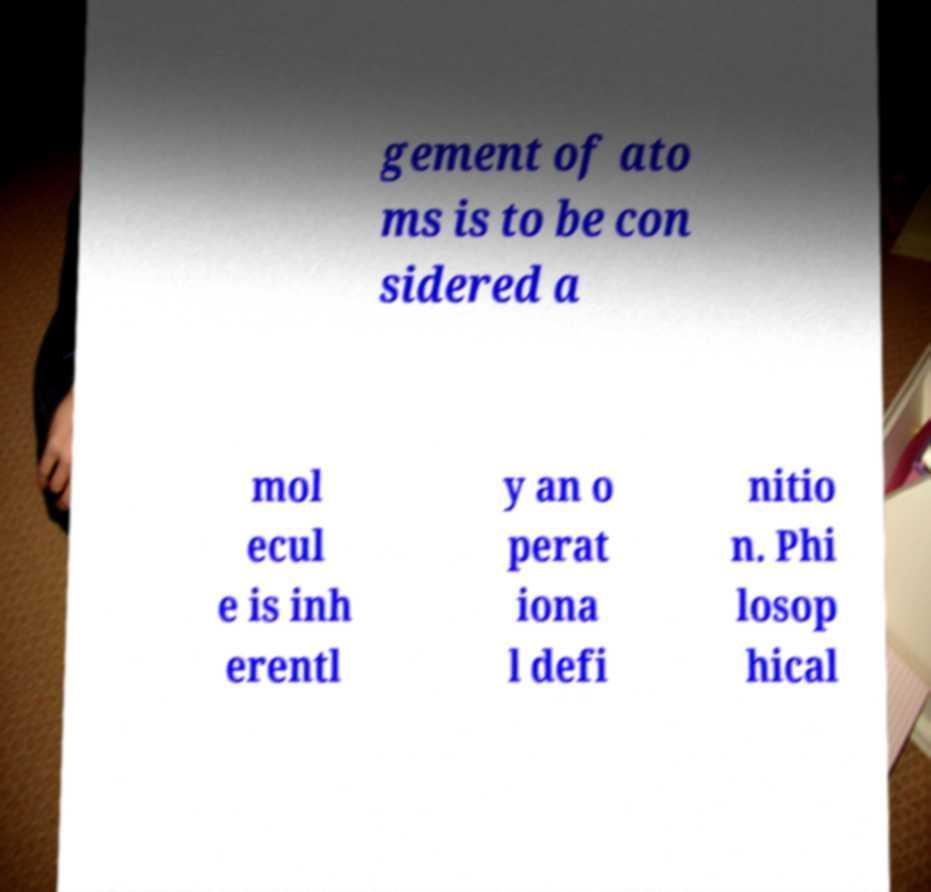Can you accurately transcribe the text from the provided image for me? gement of ato ms is to be con sidered a mol ecul e is inh erentl y an o perat iona l defi nitio n. Phi losop hical 